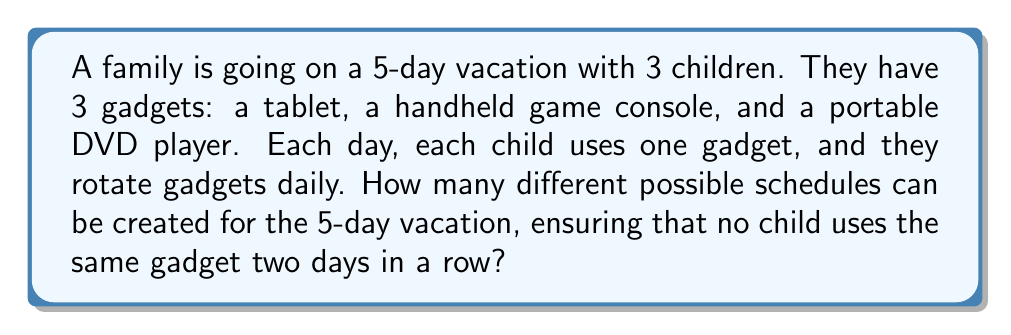Teach me how to tackle this problem. Let's approach this step-by-step:

1) First, let's consider the number of ways to distribute the gadgets on the first day. This is a straightforward permutation of 3 gadgets among 3 children:

   $$3! = 3 \times 2 \times 1 = 6$$

2) For each subsequent day, each child must use a different gadget than the one they used the previous day. This means that for each child, there are 2 choices of gadgets.

3) Since there are 3 children, and each has 2 choices, the number of ways to distribute gadgets on each day after the first day is:

   $$2 \times 2 \times 2 = 2^3 = 8$$

4) This distribution repeats for the remaining 4 days of the vacation.

5) Using the multiplication principle, the total number of possible schedules is:

   $$6 \times 8^4 = 6 \times 4096 = 24,576$$

Therefore, there are 24,576 different possible schedules for the 5-day vacation.
Answer: 24,576 